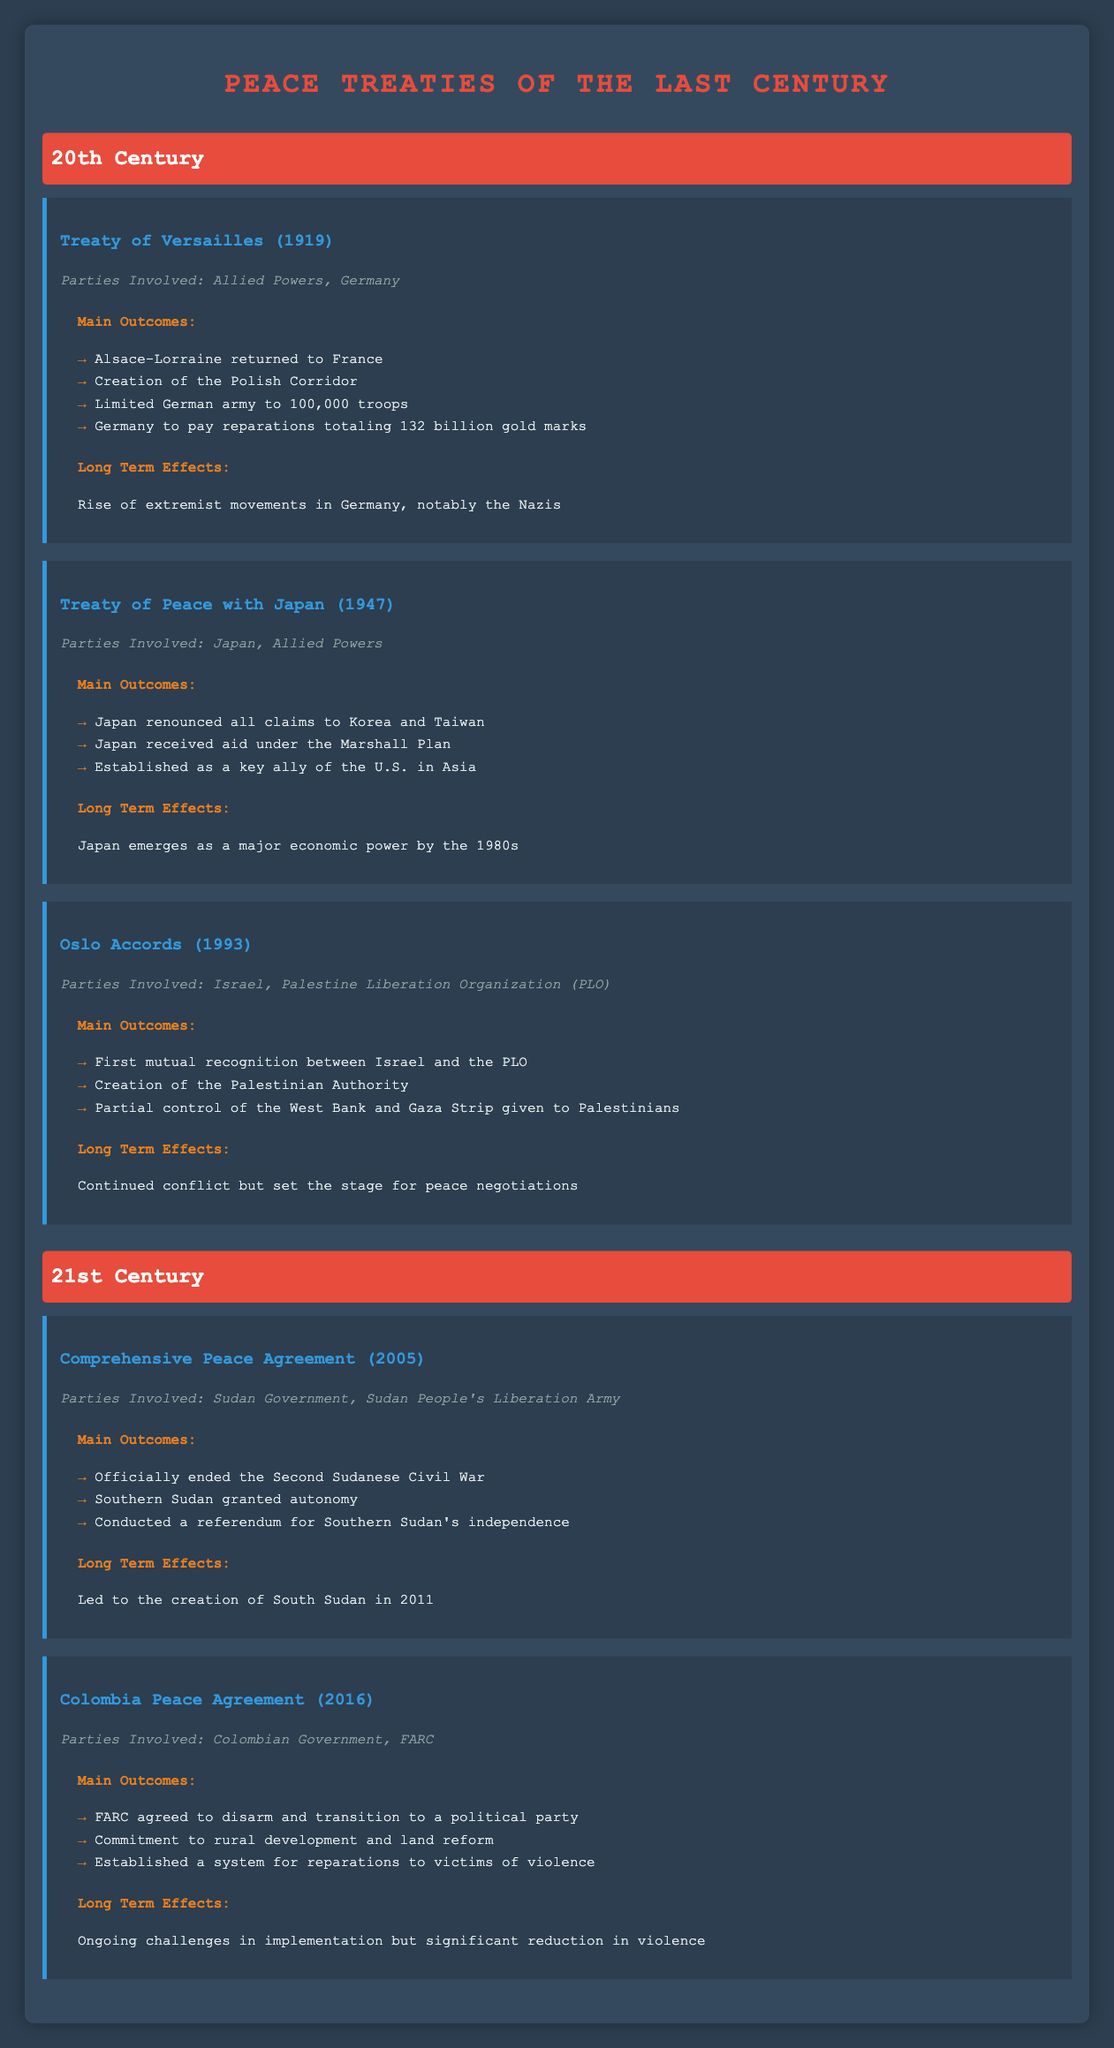What parties were involved in the Treaty of Versailles? The Treaty of Versailles involved two primary parties: the Allied Powers and Germany. This information is found directly under the treaty title in the table.
Answer: Allied Powers, Germany What were the main economic reparations imposed on Germany by the Treaty of Versailles? The table states that Germany was required to pay reparations totaling 132 billion gold marks. This specific information can be found in the section detailing the main outcomes of the Treaty of Versailles.
Answer: Germany to pay reparations totaling 132 billion gold marks Did the Oslo Accords lead to the complete resolution of conflict between Israel and the PLO? The long-term effects of the Oslo Accords show that, although they set the stage for peace negotiations, the conflict continued instead of being completely resolved. This is explicitly mentioned in the table under the long-term effects of the treaty.
Answer: No Which peace treaty resulted in the creation of an autonomous region in Southern Sudan? The Comprehensive Peace Agreement in 2005 officially ended the Second Sudanese Civil War and granted Southern Sudan autonomy, which is clearly stated in the main outcomes of the treaty.
Answer: Comprehensive Peace Agreement (2005) How many treaties listed in the table involved the recognition of parties? There are two treaties that specifically mention mutual recognition: the Oslo Accords (1993) which highlights the first mutual recognition between Israel and the PLO, and the Comprehensive Peace Agreement (2005) which implicitly involves recognition between the Sudan Government and the Sudan People's Liberation Army. The only explicit mutual recognition is in the Oslo Accords, so the answer is one.
Answer: 1 What long-term effect did the Treaty of Peace with Japan have on Japan's economic standing? The treaty is noted for establishing Japan as a key ally of the U.S. in Asia, and the long-term effect mentioned is that Japan emerged as a major economic power by the 1980s. This information is derived from the long-term effects section of the treaty.
Answer: Japan emerges as a major economic power by the 1980s Which treaty had long-term effects linked to extremist movements in Germany? The long-term effects of the Treaty of Versailles indicated a rise of extremist movements in Germany, specifically the Nazis. This information is laid out in the long-term effects section of the treaty.
Answer: Treaty of Versailles (1919) What was the main outcome related to land reform in the Colombia Peace Agreement? One of the main outcomes of the Colombia Peace Agreement was a commitment to rural development and land reform, detailed directly in the outcomes of the treaty.
Answer: Commitment to rural development and land reform 